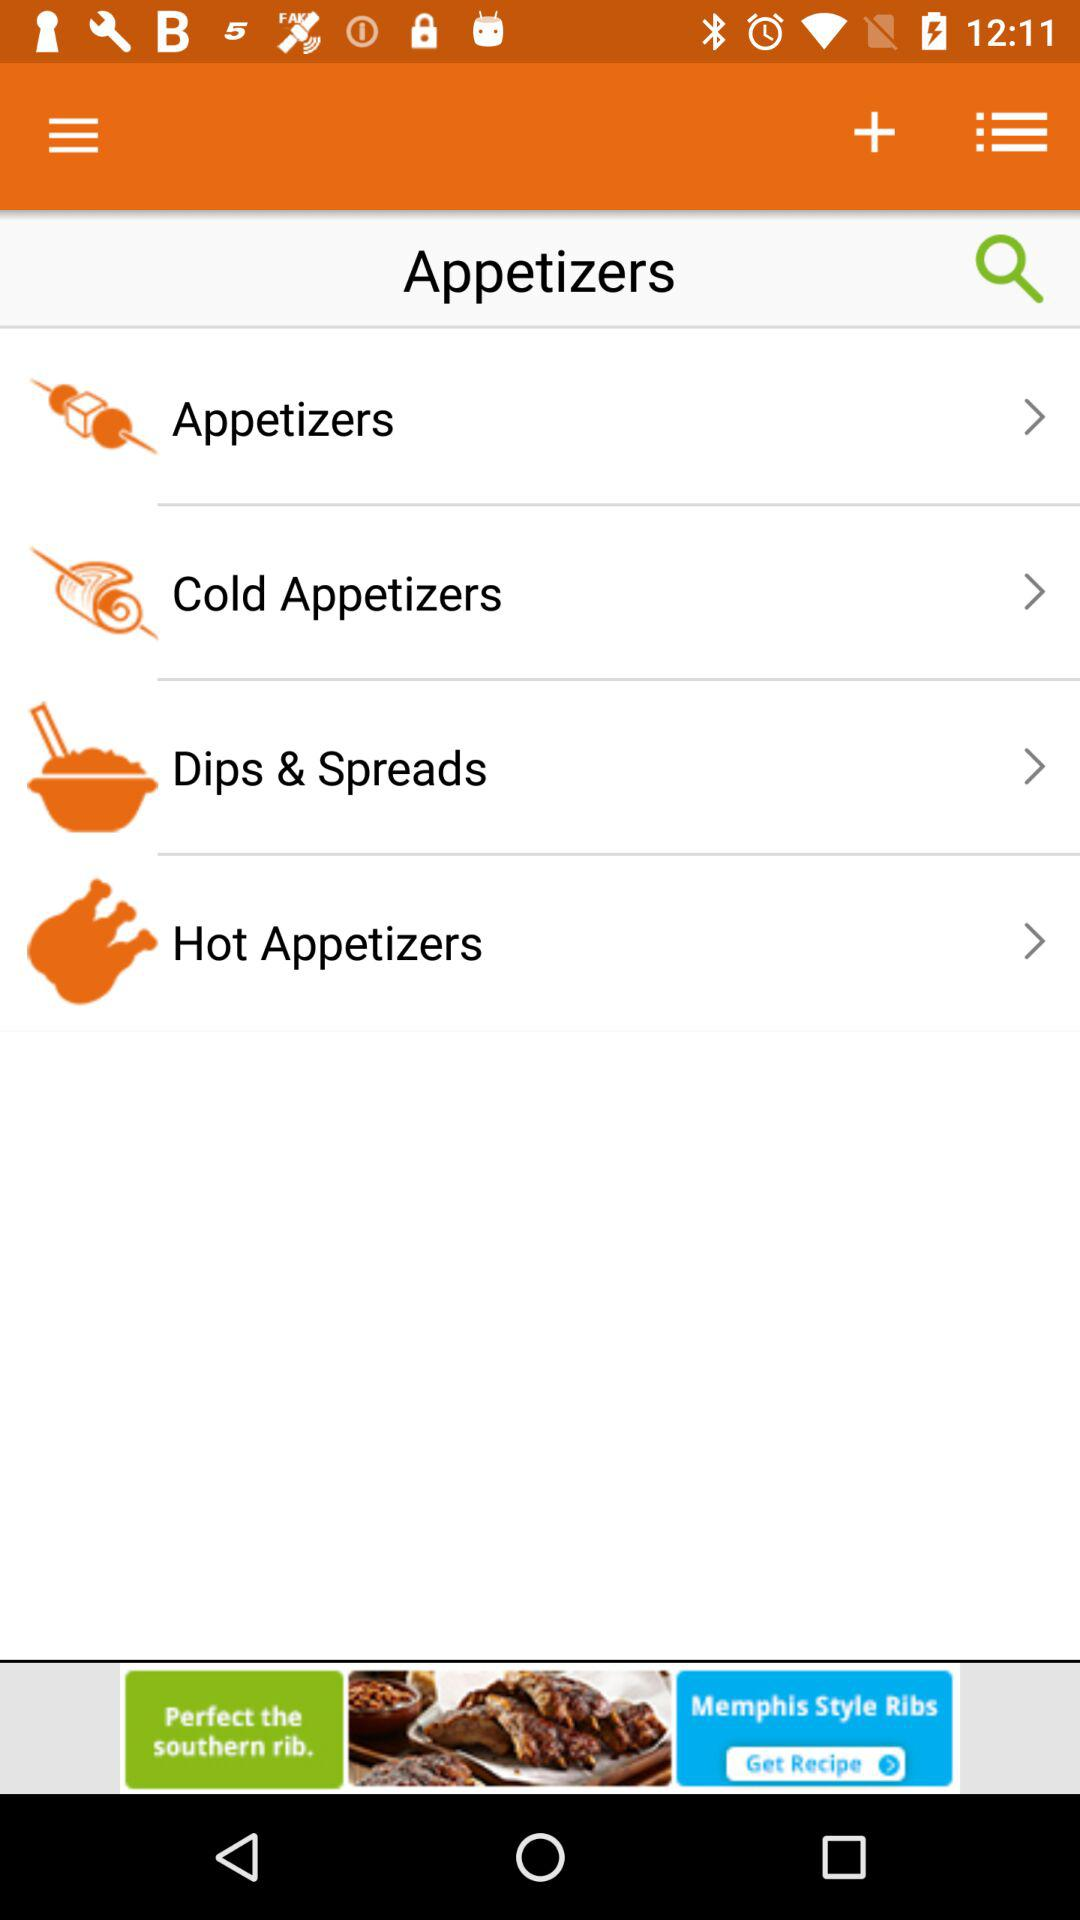How many more appetizers are there than dips and spreads?
Answer the question using a single word or phrase. 2 